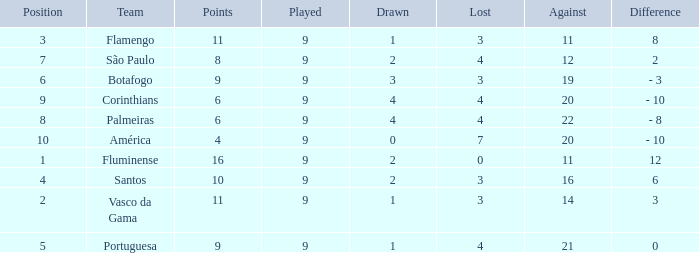Which Lost is the highest one that has a Drawn smaller than 4, and a Played smaller than 9? None. 